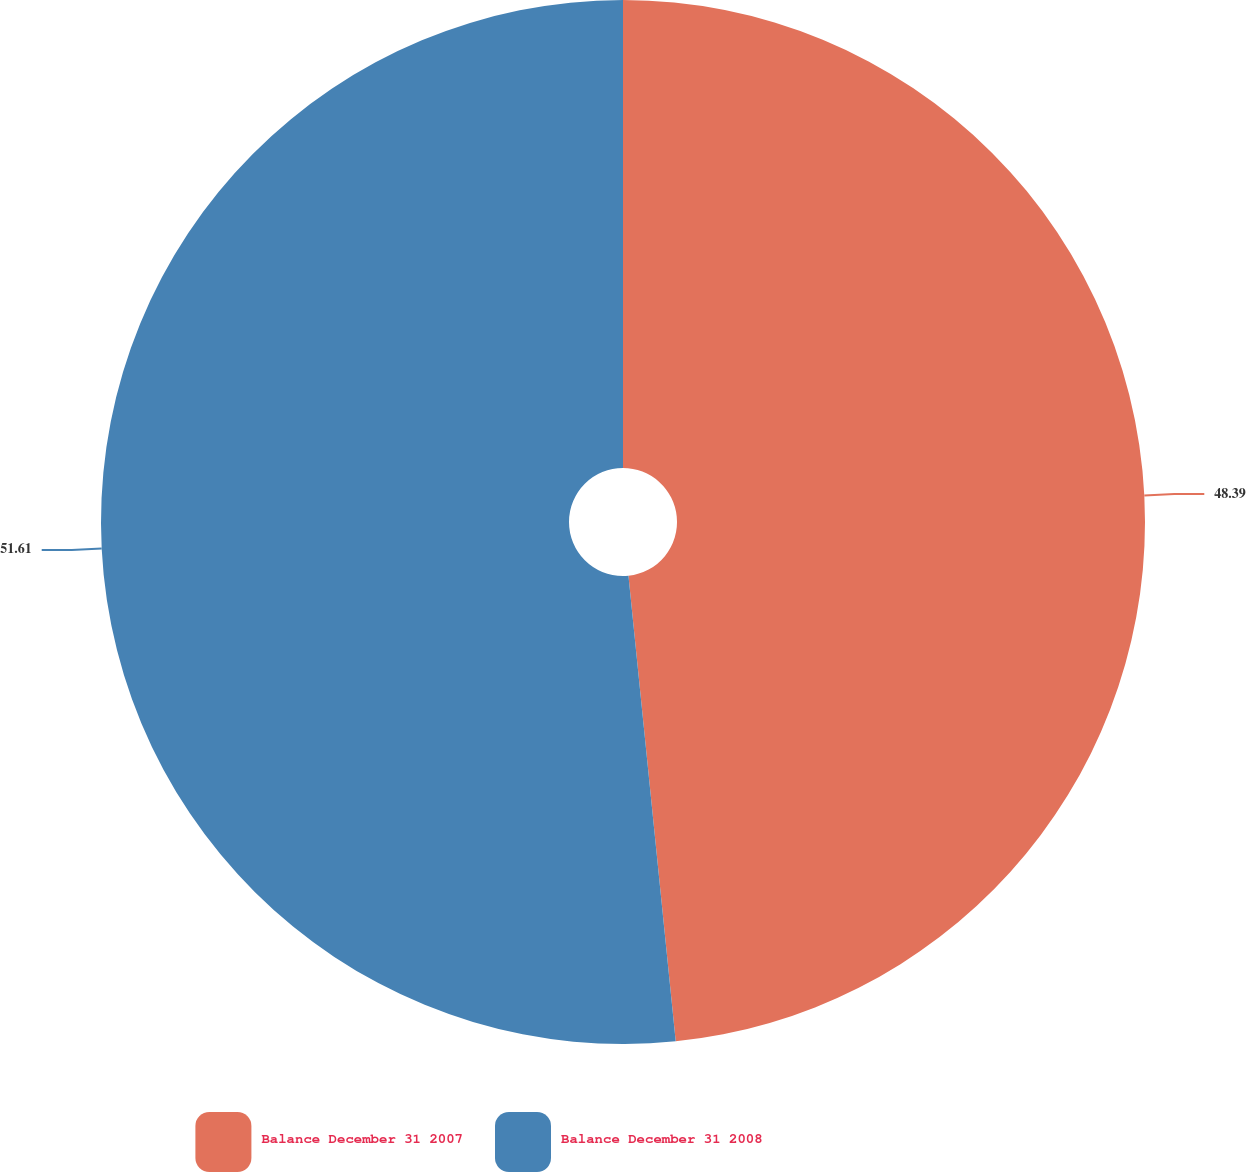Convert chart. <chart><loc_0><loc_0><loc_500><loc_500><pie_chart><fcel>Balance December 31 2007<fcel>Balance December 31 2008<nl><fcel>48.39%<fcel>51.61%<nl></chart> 